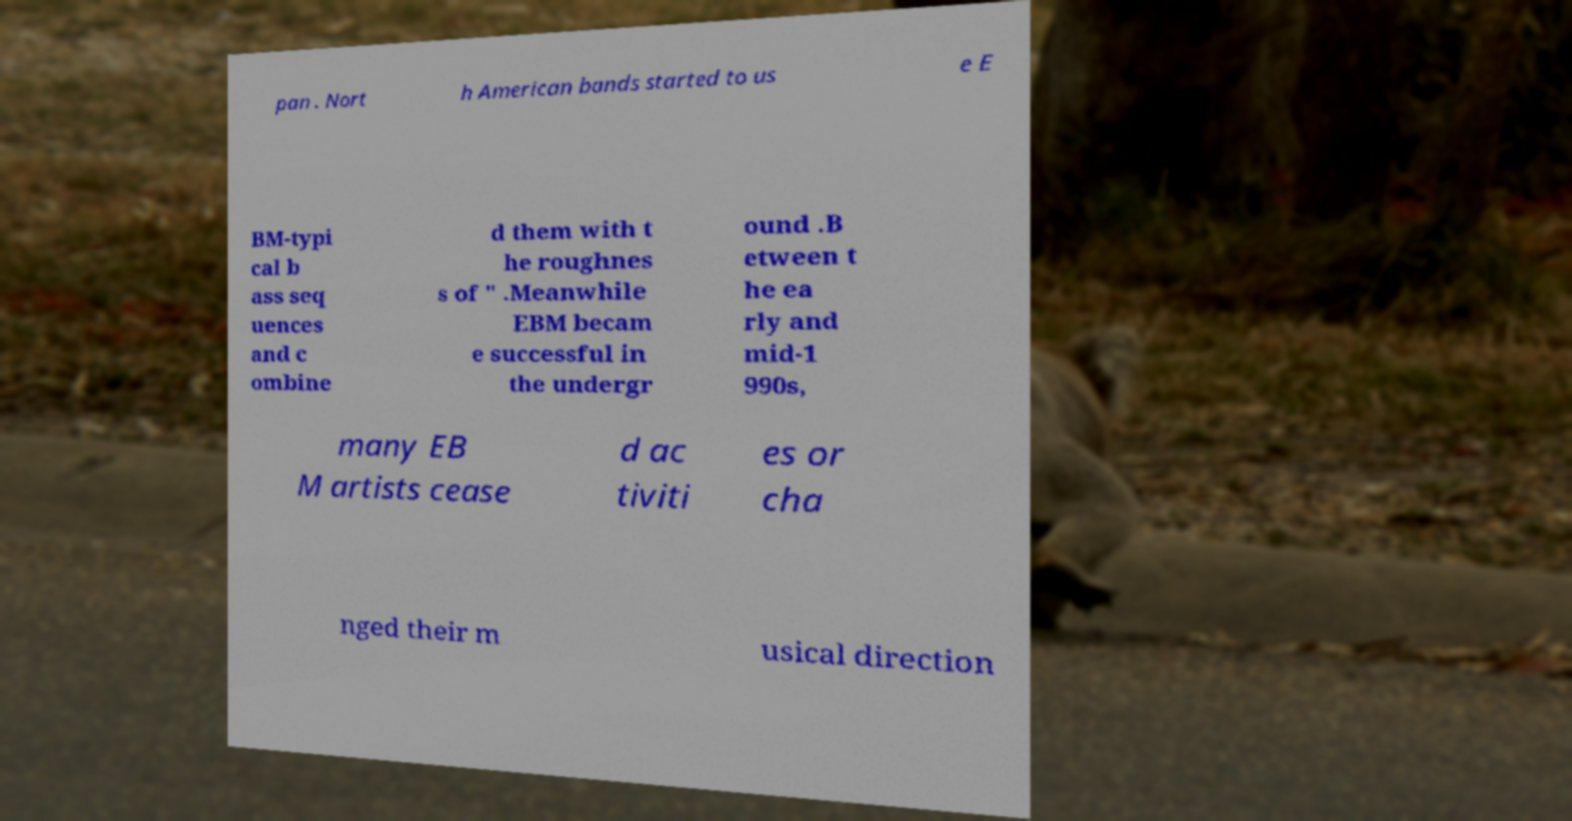What messages or text are displayed in this image? I need them in a readable, typed format. pan . Nort h American bands started to us e E BM-typi cal b ass seq uences and c ombine d them with t he roughnes s of " .Meanwhile EBM becam e successful in the undergr ound .B etween t he ea rly and mid-1 990s, many EB M artists cease d ac tiviti es or cha nged their m usical direction 